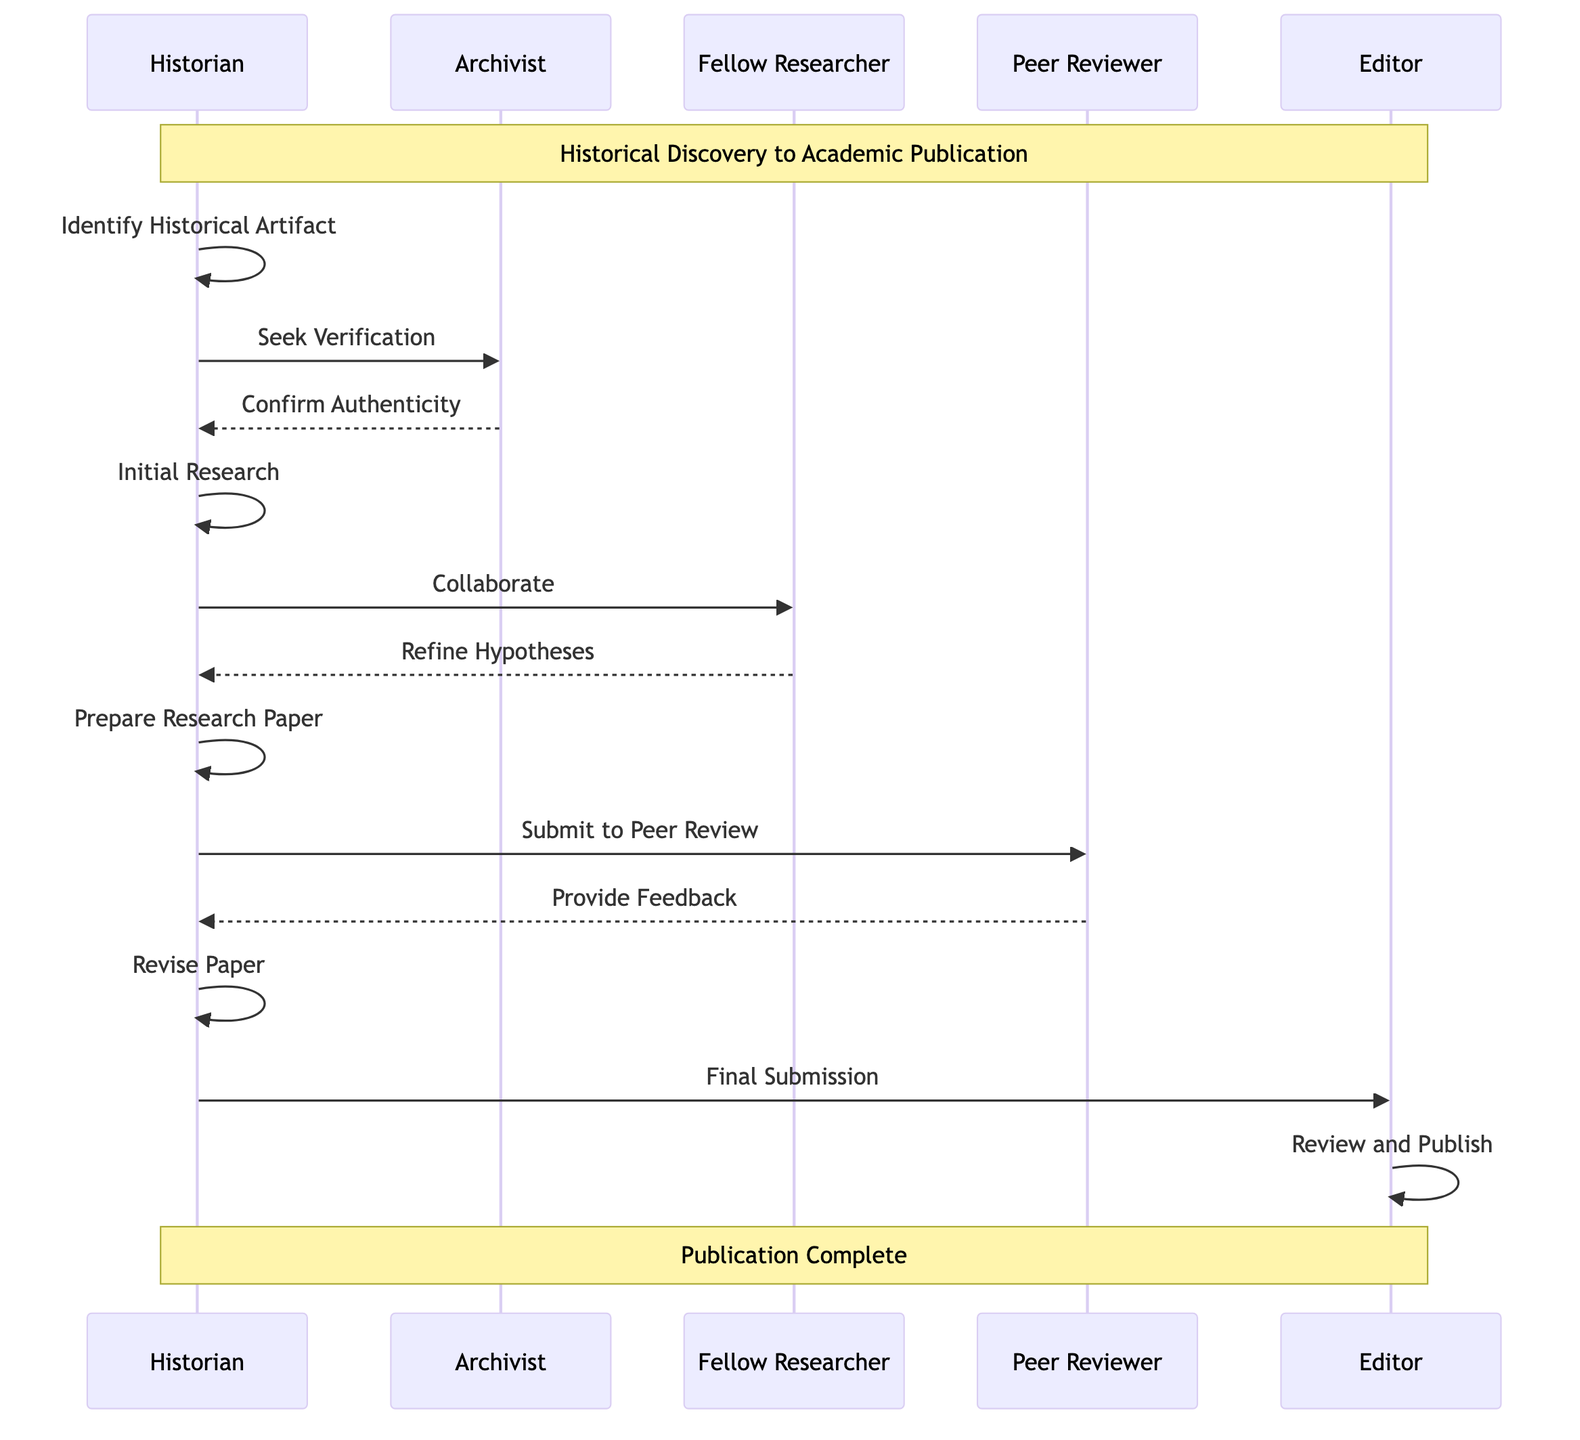What is the first step in the sequence? The sequence starts with the "Identify Historical Artifact" step where the Historian discovers a promising historical artifact.
Answer: Identify Historical Artifact How many actors are involved in the process? There are five distinct participants involved in the process: Historian, Archivist, Fellow Researcher, Peer Reviewer, and Editor.
Answer: 5 What action does the Historian take immediately after initial research? After conducting initial research, the Historian collaborates with a Fellow Researcher to broaden understanding and refine hypotheses.
Answer: Collaborate with Fellow Researcher What feedback mechanism is present in the sequence? The Peer Reviewer evaluates the paper and provides feedback during the peer review process, which is crucial for the revision step.
Answer: Provide Feedback In which step does the Historian submit the revised paper? The revised paper is submitted to the journal editor for final approval in the "Final Submission" step.
Answer: Final Submission What is the last action taken by the Editor? The last action taken by the Editor is to review and publish the paper in the academic journal upon approval.
Answer: Publish What step comes after the "Seek Verification" step? After seeking verification from the Archivist, the Historian conducts "Initial Research" to gather more information regarding the historical artifact.
Answer: Initial Research Which actor is responsible for confirming the authenticity of the artifact? The Archivist is the actor who confirms the authenticity of the artifact after the Historian seeks verification.
Answer: Archivist What is the role of Fellow Researcher in the sequence? The Fellow Researcher collaborates with the Historian to broaden understanding and refine the hypotheses related to the historical artifact.
Answer: Collaborate 